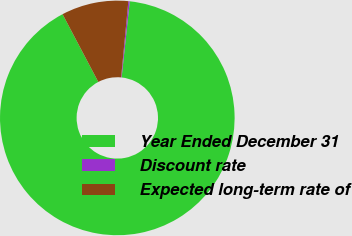Convert chart to OTSL. <chart><loc_0><loc_0><loc_500><loc_500><pie_chart><fcel>Year Ended December 31<fcel>Discount rate<fcel>Expected long-term rate of<nl><fcel>90.58%<fcel>0.19%<fcel>9.23%<nl></chart> 